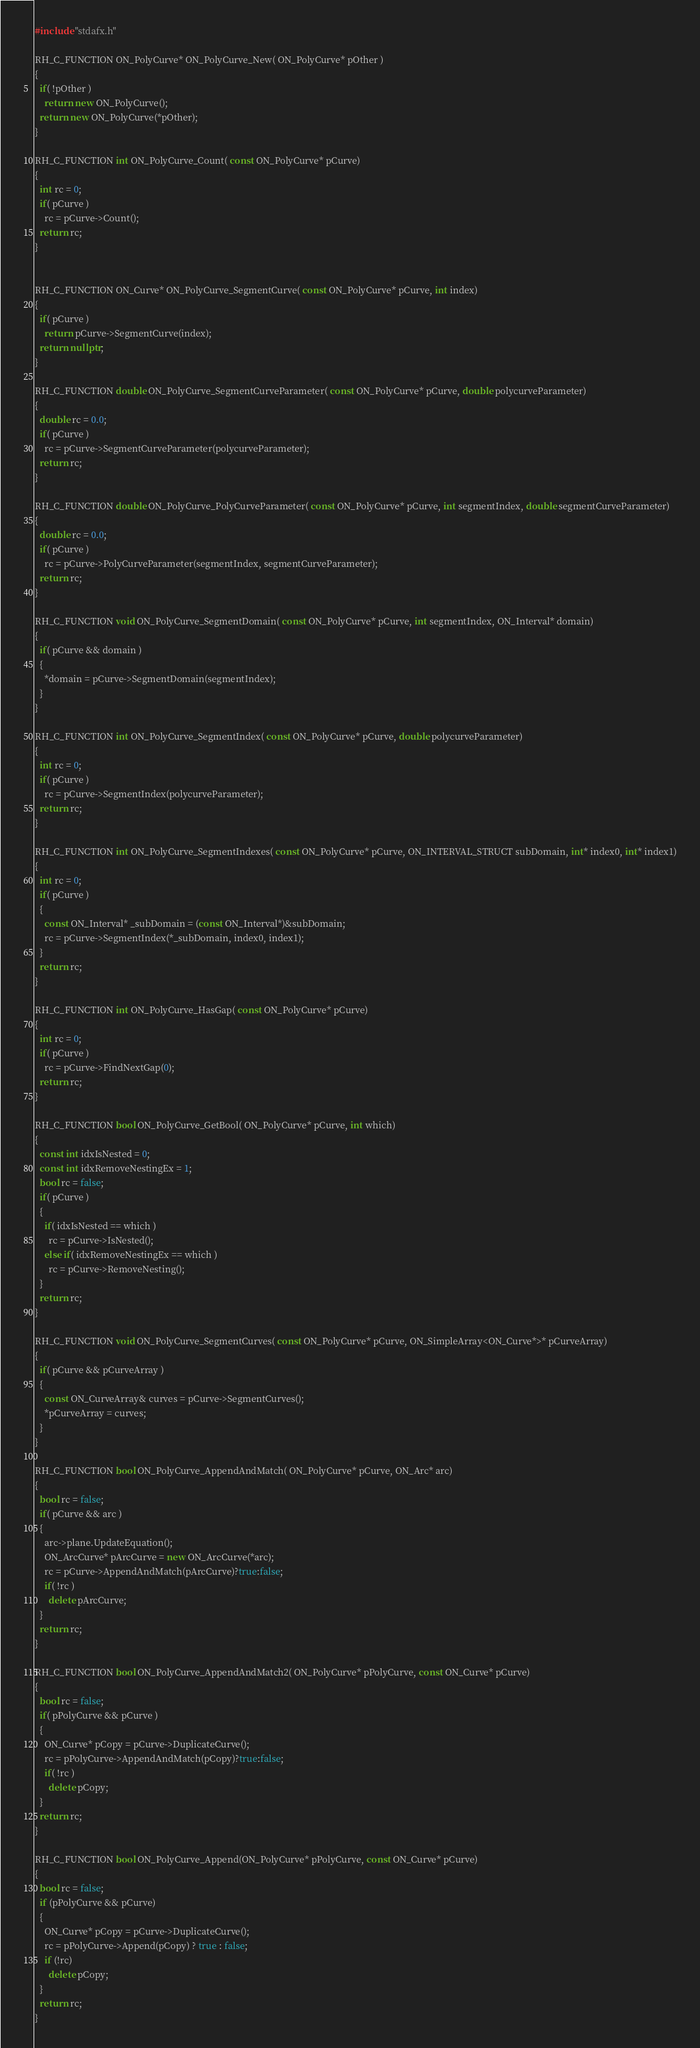<code> <loc_0><loc_0><loc_500><loc_500><_C++_>#include "stdafx.h"

RH_C_FUNCTION ON_PolyCurve* ON_PolyCurve_New( ON_PolyCurve* pOther )
{
  if( !pOther )
    return new ON_PolyCurve();
  return new ON_PolyCurve(*pOther);
}

RH_C_FUNCTION int ON_PolyCurve_Count( const ON_PolyCurve* pCurve)
{
  int rc = 0;
  if( pCurve )
    rc = pCurve->Count();
  return rc;
}


RH_C_FUNCTION ON_Curve* ON_PolyCurve_SegmentCurve( const ON_PolyCurve* pCurve, int index)
{
  if( pCurve )
    return pCurve->SegmentCurve(index);
  return nullptr;
}

RH_C_FUNCTION double ON_PolyCurve_SegmentCurveParameter( const ON_PolyCurve* pCurve, double polycurveParameter)
{
  double rc = 0.0;
  if( pCurve )
    rc = pCurve->SegmentCurveParameter(polycurveParameter);
  return rc;
}

RH_C_FUNCTION double ON_PolyCurve_PolyCurveParameter( const ON_PolyCurve* pCurve, int segmentIndex, double segmentCurveParameter)
{
  double rc = 0.0;
  if( pCurve )
    rc = pCurve->PolyCurveParameter(segmentIndex, segmentCurveParameter);
  return rc;
}

RH_C_FUNCTION void ON_PolyCurve_SegmentDomain( const ON_PolyCurve* pCurve, int segmentIndex, ON_Interval* domain)
{
  if( pCurve && domain )
  {
    *domain = pCurve->SegmentDomain(segmentIndex);
  }
}

RH_C_FUNCTION int ON_PolyCurve_SegmentIndex( const ON_PolyCurve* pCurve, double polycurveParameter)
{
  int rc = 0;
  if( pCurve )
    rc = pCurve->SegmentIndex(polycurveParameter);
  return rc;
}

RH_C_FUNCTION int ON_PolyCurve_SegmentIndexes( const ON_PolyCurve* pCurve, ON_INTERVAL_STRUCT subDomain, int* index0, int* index1)
{
  int rc = 0;
  if( pCurve )
  {
    const ON_Interval* _subDomain = (const ON_Interval*)&subDomain;
    rc = pCurve->SegmentIndex(*_subDomain, index0, index1);
  }
  return rc;
}

RH_C_FUNCTION int ON_PolyCurve_HasGap( const ON_PolyCurve* pCurve)
{
  int rc = 0;
  if( pCurve )
    rc = pCurve->FindNextGap(0);
  return rc;
}

RH_C_FUNCTION bool ON_PolyCurve_GetBool( ON_PolyCurve* pCurve, int which)
{
  const int idxIsNested = 0;
  const int idxRemoveNestingEx = 1;
  bool rc = false;
  if( pCurve )
  {
    if( idxIsNested == which )
      rc = pCurve->IsNested();
    else if( idxRemoveNestingEx == which )
      rc = pCurve->RemoveNesting();
  }
  return rc;
}

RH_C_FUNCTION void ON_PolyCurve_SegmentCurves( const ON_PolyCurve* pCurve, ON_SimpleArray<ON_Curve*>* pCurveArray)
{
  if( pCurve && pCurveArray )
  {
    const ON_CurveArray& curves = pCurve->SegmentCurves();
    *pCurveArray = curves;
  }
}

RH_C_FUNCTION bool ON_PolyCurve_AppendAndMatch( ON_PolyCurve* pCurve, ON_Arc* arc)
{
  bool rc = false;
  if( pCurve && arc )
  {
    arc->plane.UpdateEquation();
    ON_ArcCurve* pArcCurve = new ON_ArcCurve(*arc);
    rc = pCurve->AppendAndMatch(pArcCurve)?true:false;
    if( !rc )
      delete pArcCurve;
  }
  return rc;
}

RH_C_FUNCTION bool ON_PolyCurve_AppendAndMatch2( ON_PolyCurve* pPolyCurve, const ON_Curve* pCurve)
{
  bool rc = false;
  if( pPolyCurve && pCurve )
  {
    ON_Curve* pCopy = pCurve->DuplicateCurve();
    rc = pPolyCurve->AppendAndMatch(pCopy)?true:false;
    if( !rc )
      delete pCopy;
  }
  return rc;
}

RH_C_FUNCTION bool ON_PolyCurve_Append(ON_PolyCurve* pPolyCurve, const ON_Curve* pCurve)
{
  bool rc = false;
  if (pPolyCurve && pCurve)
  {
    ON_Curve* pCopy = pCurve->DuplicateCurve();
    rc = pPolyCurve->Append(pCopy) ? true : false;
    if (!rc)
      delete pCopy;
  }
  return rc;
}

</code> 